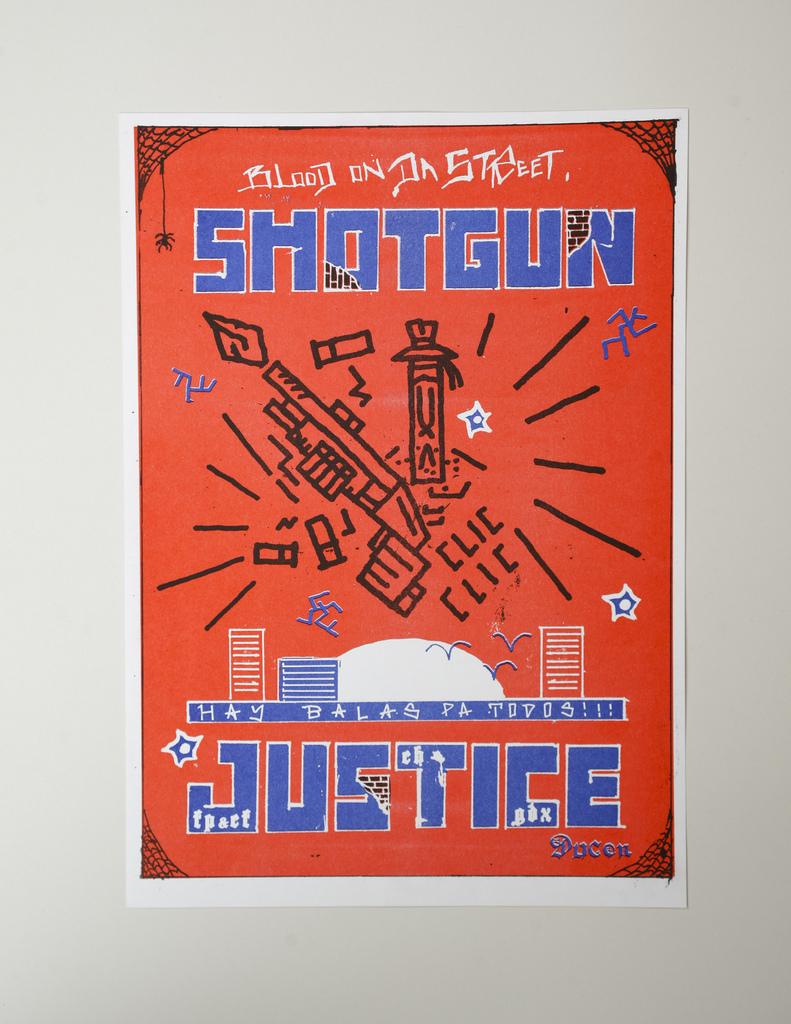What does the bottom word say?
Give a very brief answer. Justice. 